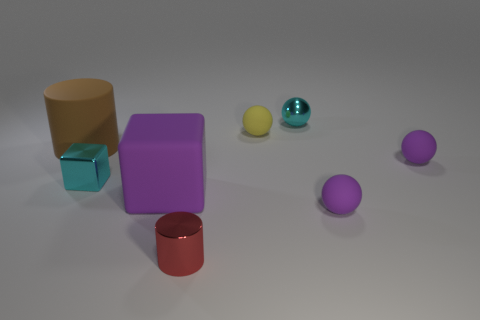What number of other objects are there of the same size as the red object?
Provide a short and direct response. 5. There is a cyan block behind the tiny red shiny thing; how big is it?
Your answer should be very brief. Small. What number of objects are matte spheres in front of the matte cylinder or cylinders that are behind the small metal cylinder?
Offer a terse response. 3. Is there anything else that has the same color as the large rubber cylinder?
Provide a succinct answer. No. Are there the same number of small yellow things that are behind the red object and metal balls in front of the large brown matte cylinder?
Your answer should be compact. No. Is the number of red cylinders behind the tiny metallic cylinder greater than the number of small yellow matte spheres?
Your response must be concise. No. How many objects are balls on the right side of the cyan metallic sphere or cyan metal objects?
Give a very brief answer. 4. What number of tiny blocks are made of the same material as the red object?
Keep it short and to the point. 1. There is a small shiny object that is the same color as the tiny shiny block; what is its shape?
Make the answer very short. Sphere. Are there any tiny cyan objects of the same shape as the big brown object?
Your response must be concise. No. 